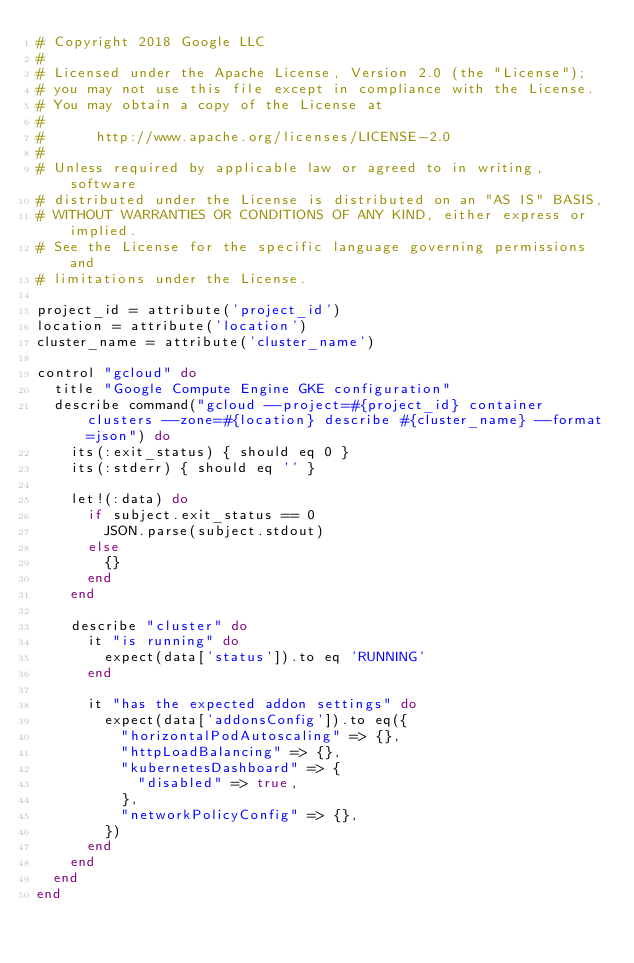Convert code to text. <code><loc_0><loc_0><loc_500><loc_500><_Ruby_># Copyright 2018 Google LLC
#
# Licensed under the Apache License, Version 2.0 (the "License");
# you may not use this file except in compliance with the License.
# You may obtain a copy of the License at
#
#      http://www.apache.org/licenses/LICENSE-2.0
#
# Unless required by applicable law or agreed to in writing, software
# distributed under the License is distributed on an "AS IS" BASIS,
# WITHOUT WARRANTIES OR CONDITIONS OF ANY KIND, either express or implied.
# See the License for the specific language governing permissions and
# limitations under the License.

project_id = attribute('project_id')
location = attribute('location')
cluster_name = attribute('cluster_name')

control "gcloud" do
  title "Google Compute Engine GKE configuration"
  describe command("gcloud --project=#{project_id} container clusters --zone=#{location} describe #{cluster_name} --format=json") do
    its(:exit_status) { should eq 0 }
    its(:stderr) { should eq '' }

    let!(:data) do
      if subject.exit_status == 0
        JSON.parse(subject.stdout)
      else
        {}
      end
    end

    describe "cluster" do
      it "is running" do
        expect(data['status']).to eq 'RUNNING'
      end

      it "has the expected addon settings" do
        expect(data['addonsConfig']).to eq({
          "horizontalPodAutoscaling" => {},
          "httpLoadBalancing" => {},
          "kubernetesDashboard" => {
            "disabled" => true,
          },
          "networkPolicyConfig" => {},
        })
      end
    end
  end
end
</code> 